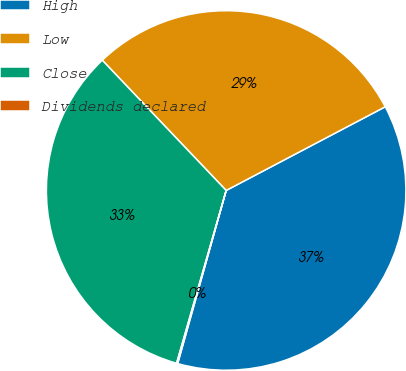<chart> <loc_0><loc_0><loc_500><loc_500><pie_chart><fcel>High<fcel>Low<fcel>Close<fcel>Dividends declared<nl><fcel>37.05%<fcel>29.39%<fcel>33.45%<fcel>0.1%<nl></chart> 